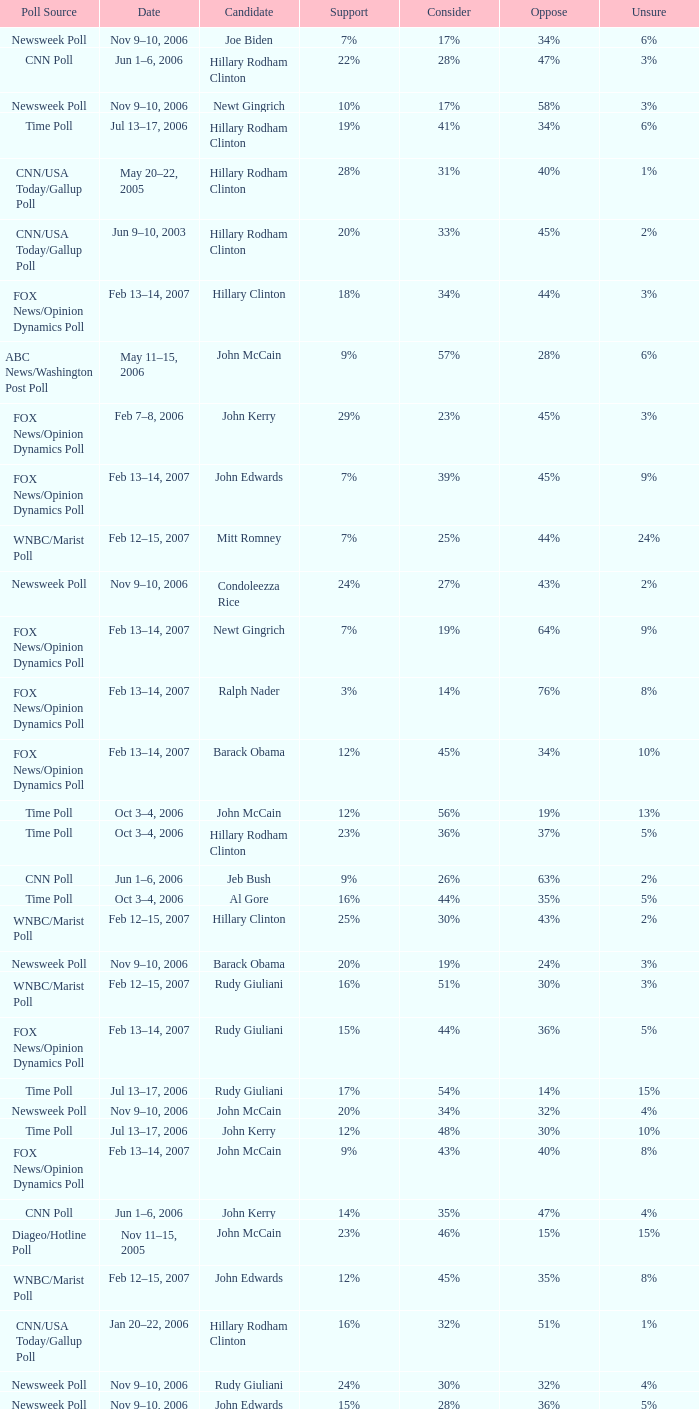What percentage of people said they would consider Rudy Giuliani as a candidate according to the Newsweek poll that showed 32% opposed him? 30%. 